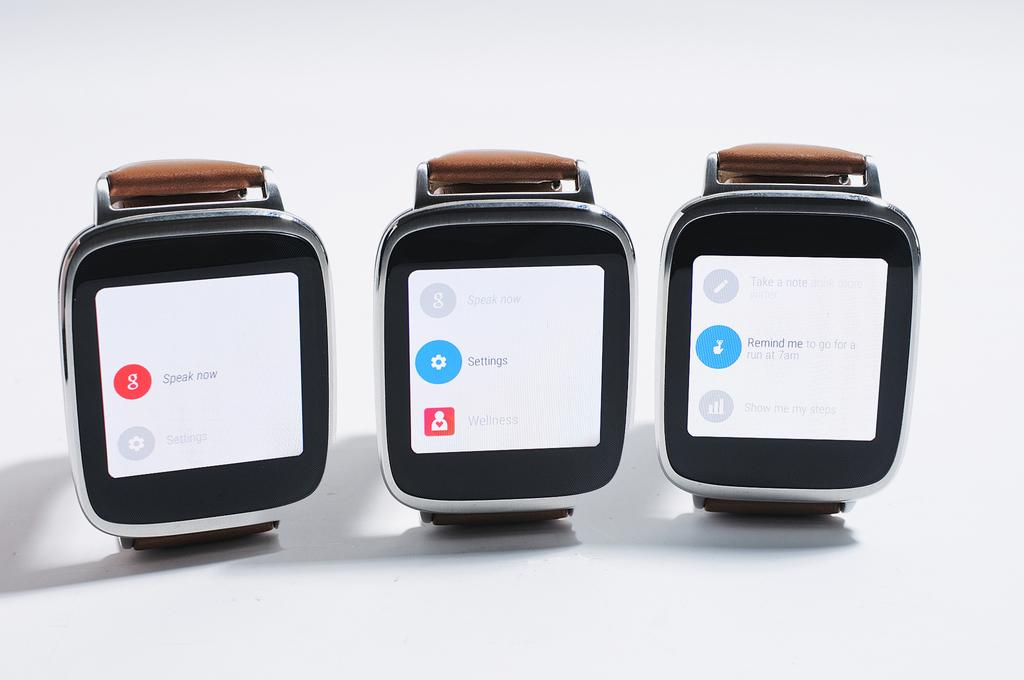Provide a one-sentence caption for the provided image. Three smart watches are all showing different apps, including a Google app and a settings app. 